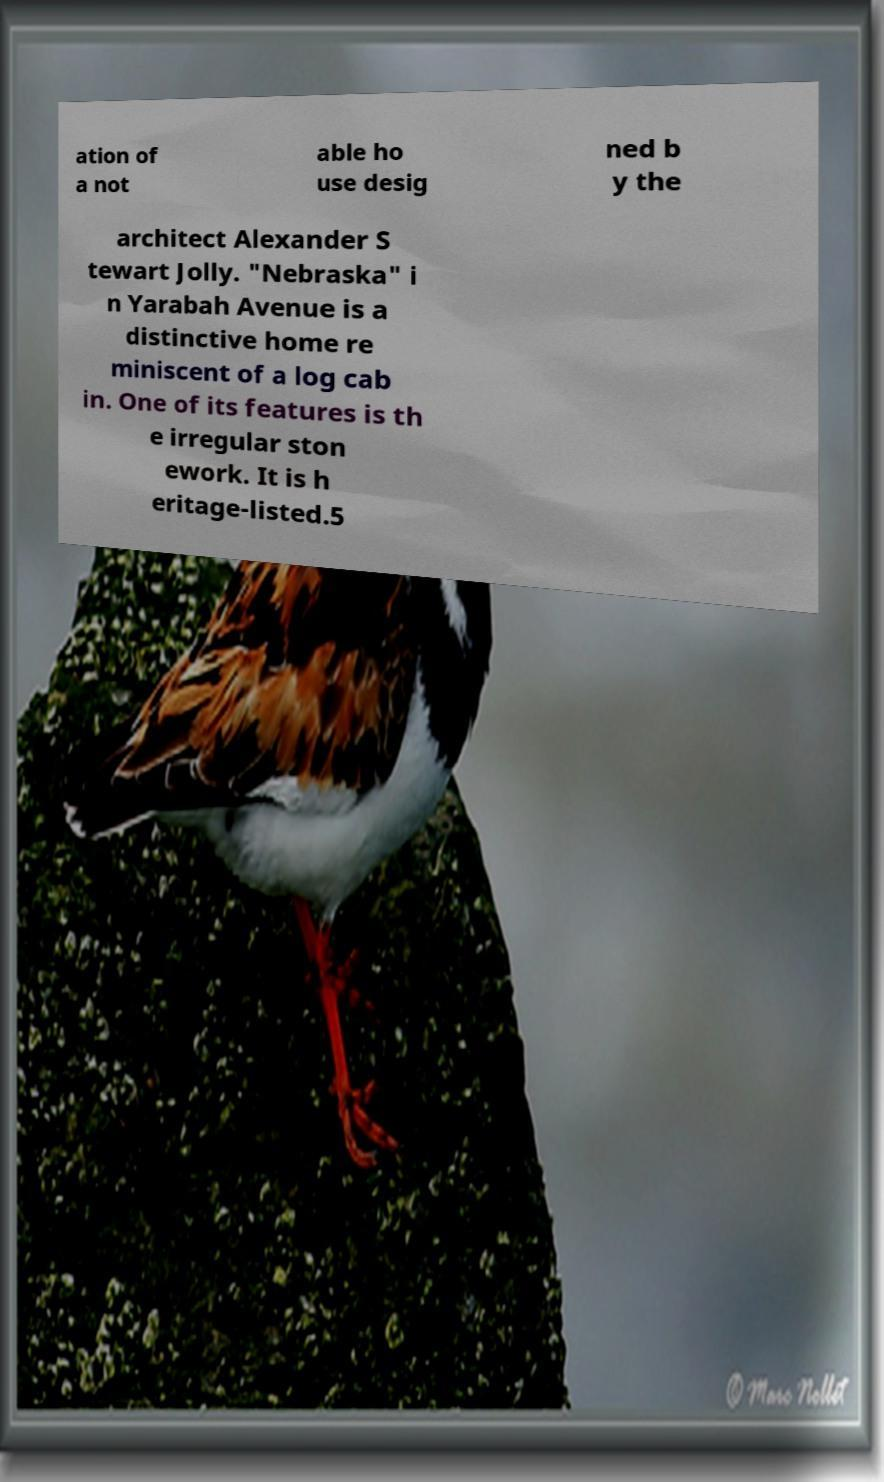Can you accurately transcribe the text from the provided image for me? ation of a not able ho use desig ned b y the architect Alexander S tewart Jolly. "Nebraska" i n Yarabah Avenue is a distinctive home re miniscent of a log cab in. One of its features is th e irregular ston ework. It is h eritage-listed.5 